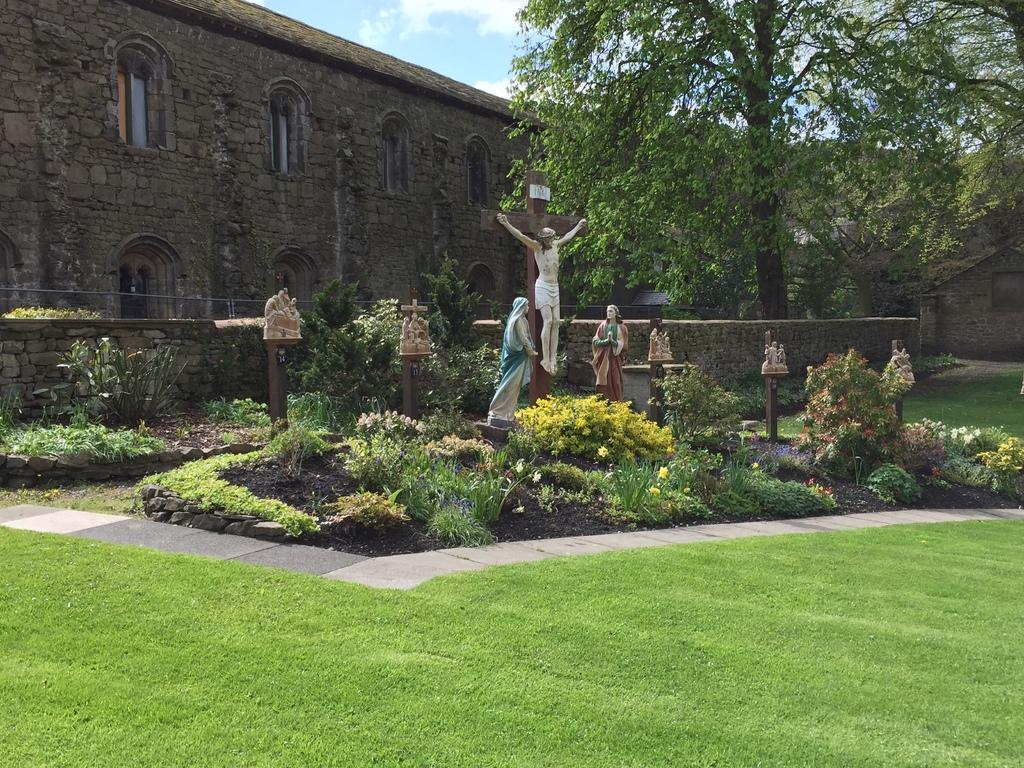What can be seen in the image that represents human-made art? There are statues in the image. What type of natural elements are present in the image? There are plants, grass, and trees in the image. What is the pathway for people to walk on in the image? There is a walkway in the image. What structures can be seen in the background of the image? There is a wall and a building in the background of the image. What is the condition of the sky in the image? The sky is clear in the image. What type of produce is being harvested from the faucet in the image? There is no faucet or produce present in the image. What vegetables are growing in the background of the image? There are no vegetables growing in the image; only plants, trees, and a building are visible in the background. 